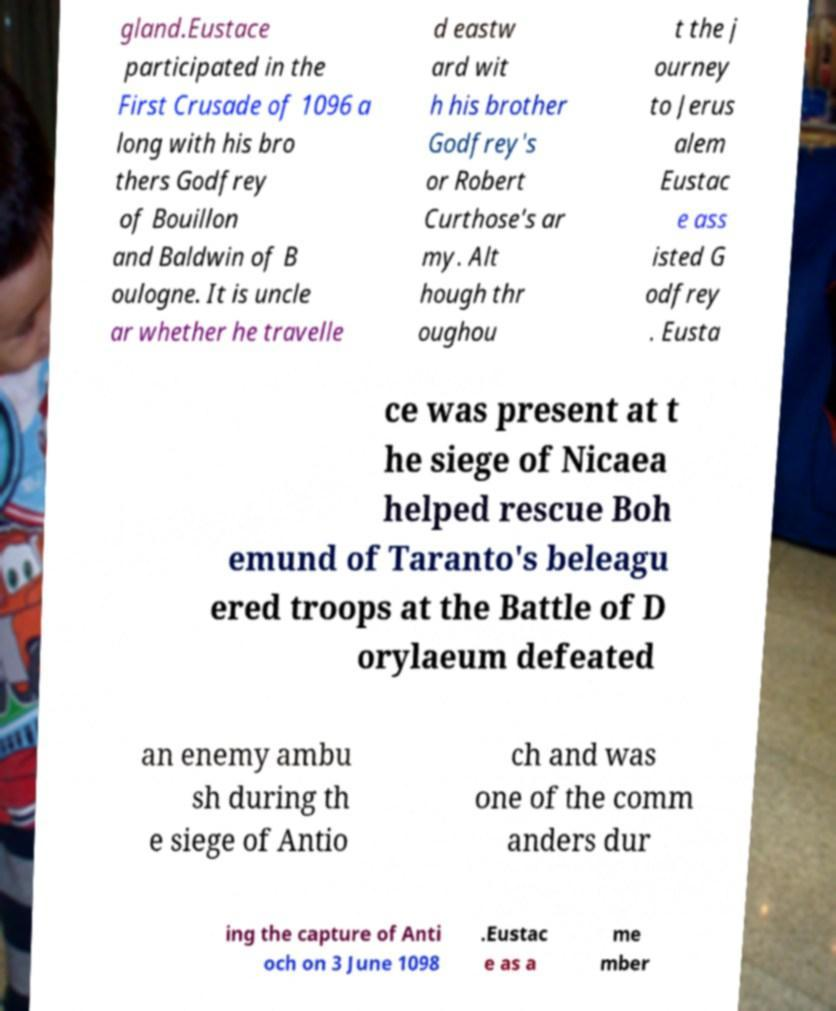Please identify and transcribe the text found in this image. gland.Eustace participated in the First Crusade of 1096 a long with his bro thers Godfrey of Bouillon and Baldwin of B oulogne. It is uncle ar whether he travelle d eastw ard wit h his brother Godfrey's or Robert Curthose's ar my. Alt hough thr oughou t the j ourney to Jerus alem Eustac e ass isted G odfrey . Eusta ce was present at t he siege of Nicaea helped rescue Boh emund of Taranto's beleagu ered troops at the Battle of D orylaeum defeated an enemy ambu sh during th e siege of Antio ch and was one of the comm anders dur ing the capture of Anti och on 3 June 1098 .Eustac e as a me mber 